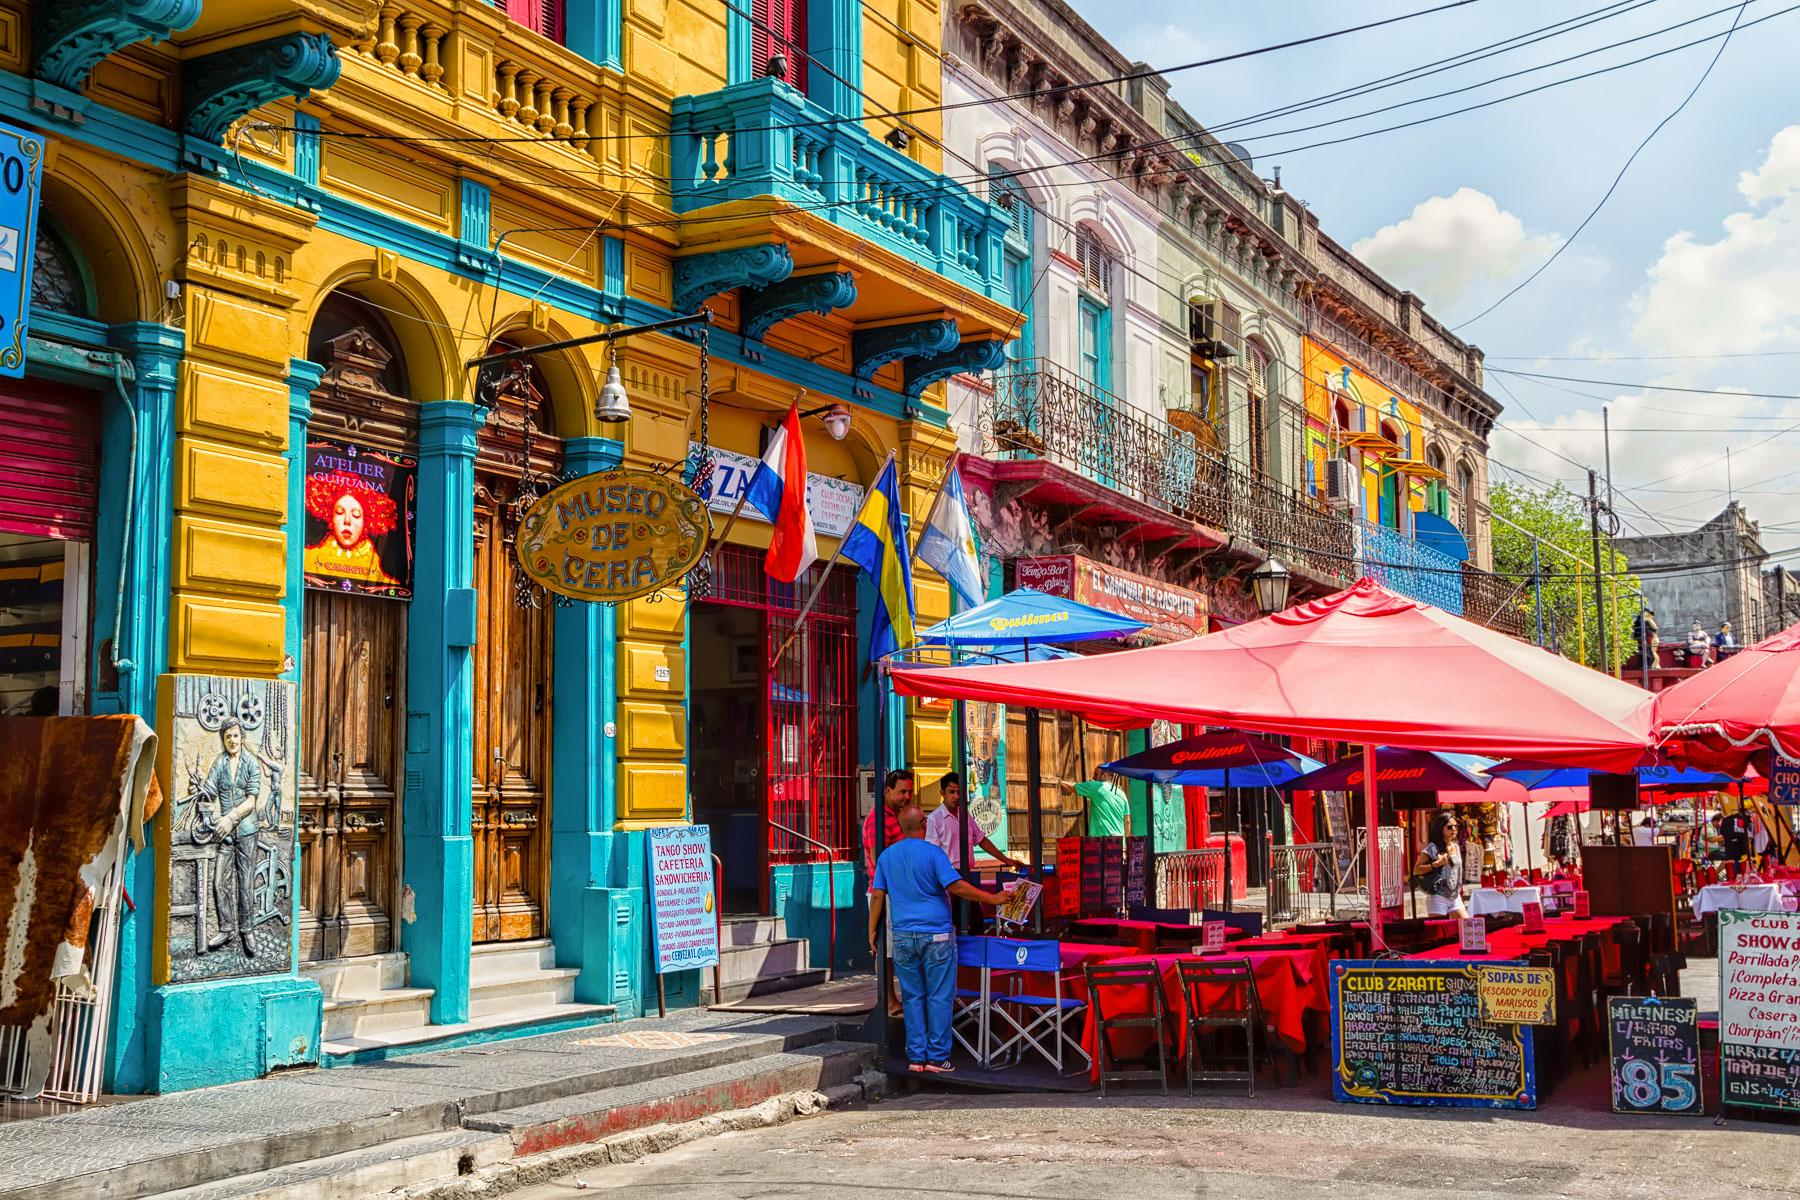What might the street look like at night? At night, the street in La Boca transforms into a different, yet equally enchanting place. The vibrant colors of the buildings are illuminated by warm streetlights, casting a golden glow. The outdoor seating areas of restaurants are alive with soft, romantic lighting, enhancing the ambiance. Tango music spills out from cafes, and street performers continue entertaining the evening crowd. The shadows add a touch of mystery, while the vivid paint reflects the streetlights, creating a magical and inviting atmosphere. It's a scene where the cultural heartbeat of Buenos Aires can truly be felt in the still of the night. What do you think it would feel like walking down this street? Walking down this street in La Boca would be an invigorating and sensory-rich experience. The vivid colors of the buildings create a cheerful and lively atmosphere, making each step feel like part of a vibrant dance. The air is filled with a blend of aromas from street food vendors and nearby restaurants, tantalizing your taste buds. The sounds of tango music and the chatter of people create a dynamic backdrop, immersing you in the local culture. The textures of the cobblestone pavement underfoot and the occasional street art mural you encounter make the walk feel like an adventure through a living gallery. The sense of history and artistic expression permeates the air, making the journey both exciting and enriching. 